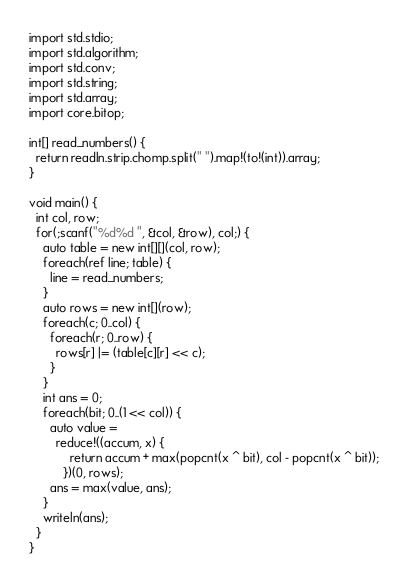Convert code to text. <code><loc_0><loc_0><loc_500><loc_500><_D_>
import std.stdio;
import std.algorithm;
import std.conv;
import std.string;
import std.array;
import core.bitop;

int[] read_numbers() {
  return readln.strip.chomp.split(" ").map!(to!(int)).array;
}

void main() {
  int col, row;
  for(;scanf("%d%d ", &col, &row), col;) {
    auto table = new int[][](col, row);
    foreach(ref line; table) {
      line = read_numbers;
    }
    auto rows = new int[](row);
    foreach(c; 0..col) {
      foreach(r; 0..row) {
        rows[r] |= (table[c][r] << c);
      }
    }
    int ans = 0;
    foreach(bit; 0..(1 << col)) {
      auto value =
        reduce!((accum, x) {
            return accum + max(popcnt(x ^ bit), col - popcnt(x ^ bit));
          })(0, rows);
      ans = max(value, ans);
    }
    writeln(ans);
  }
}</code> 